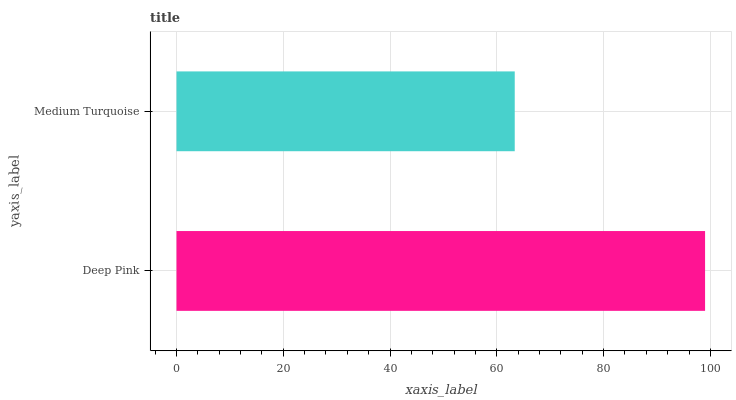Is Medium Turquoise the minimum?
Answer yes or no. Yes. Is Deep Pink the maximum?
Answer yes or no. Yes. Is Medium Turquoise the maximum?
Answer yes or no. No. Is Deep Pink greater than Medium Turquoise?
Answer yes or no. Yes. Is Medium Turquoise less than Deep Pink?
Answer yes or no. Yes. Is Medium Turquoise greater than Deep Pink?
Answer yes or no. No. Is Deep Pink less than Medium Turquoise?
Answer yes or no. No. Is Deep Pink the high median?
Answer yes or no. Yes. Is Medium Turquoise the low median?
Answer yes or no. Yes. Is Medium Turquoise the high median?
Answer yes or no. No. Is Deep Pink the low median?
Answer yes or no. No. 